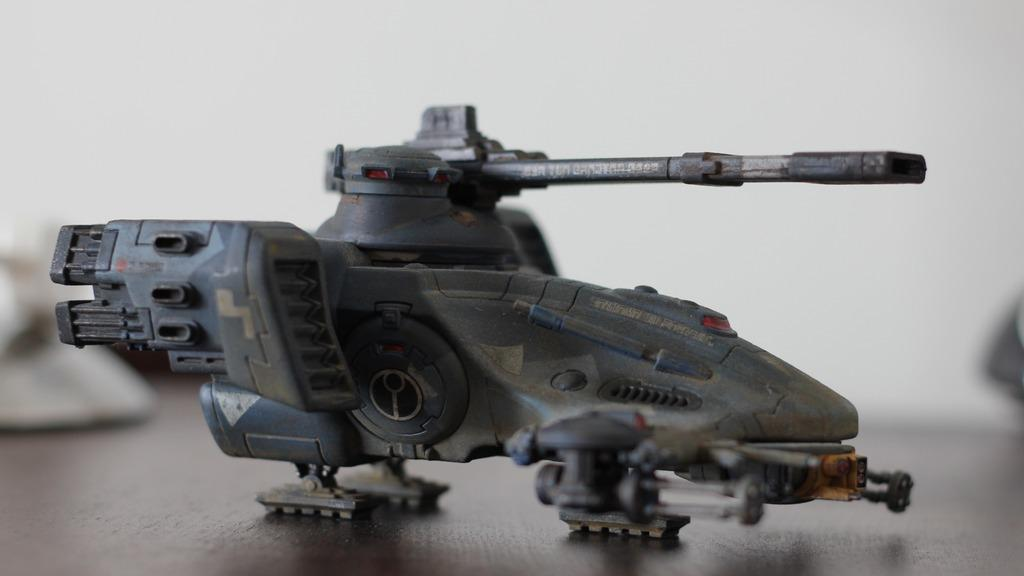What is the main subject of the image? There is a toy in the center of the image. What color is the toy? The toy is black in color. What can be seen in the background of the image? There is a wall in the background of the image. What type of back pain does the toy represent in the image? The toy does not represent any type of back pain in the image, as it is a toy and not a medical or health-related object. 